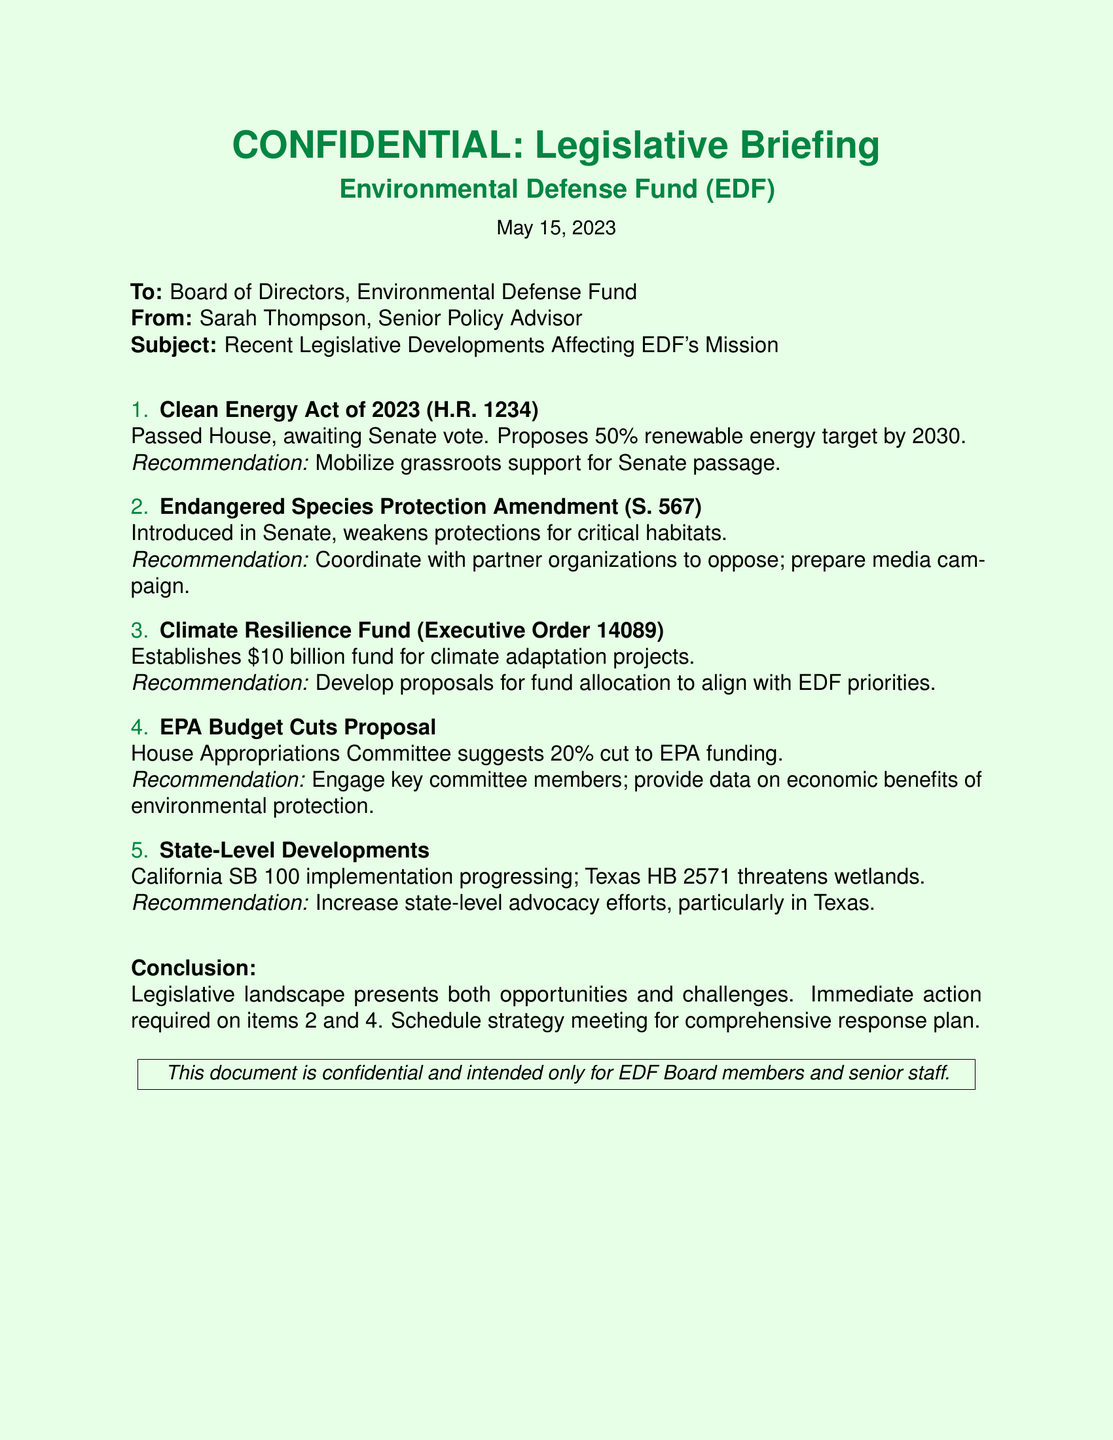what is the date of the document? The date is specified in the header of the document.
Answer: May 15, 2023 who is the author of the document? The author is mentioned at the top of the document.
Answer: Sarah Thompson what is the title of the first legislative item discussed? The title is provided as a bullet point in the enumeration section.
Answer: Clean Energy Act of 2023 what percentage of renewable energy is targeted by the Clean Energy Act? The percentage is clearly stated in the recommendation for the Clean Energy Act.
Answer: 50% what action is recommended for the Endangered Species Protection Amendment? The recommendation is explicitly mentioned following the description of the legislative item.
Answer: Coordinate with partner organizations to oppose what is the proposed budget for the Climate Resilience Fund? The proposed budget figure is indicated in the section discussing the executive order.
Answer: $10 billion which state is mentioned in relation to a threat to wetlands? The state involved is identified in the state-level developments section of the document.
Answer: Texas how much is the proposed cut to EPA funding? The proposed cut percentage is outlined in the budget cuts proposal section.
Answer: 20% what is the purpose of the final recommendation in the conclusion? The final recommendation emphasizes scheduling a meeting for a specific purpose.
Answer: Comprehensive response plan 